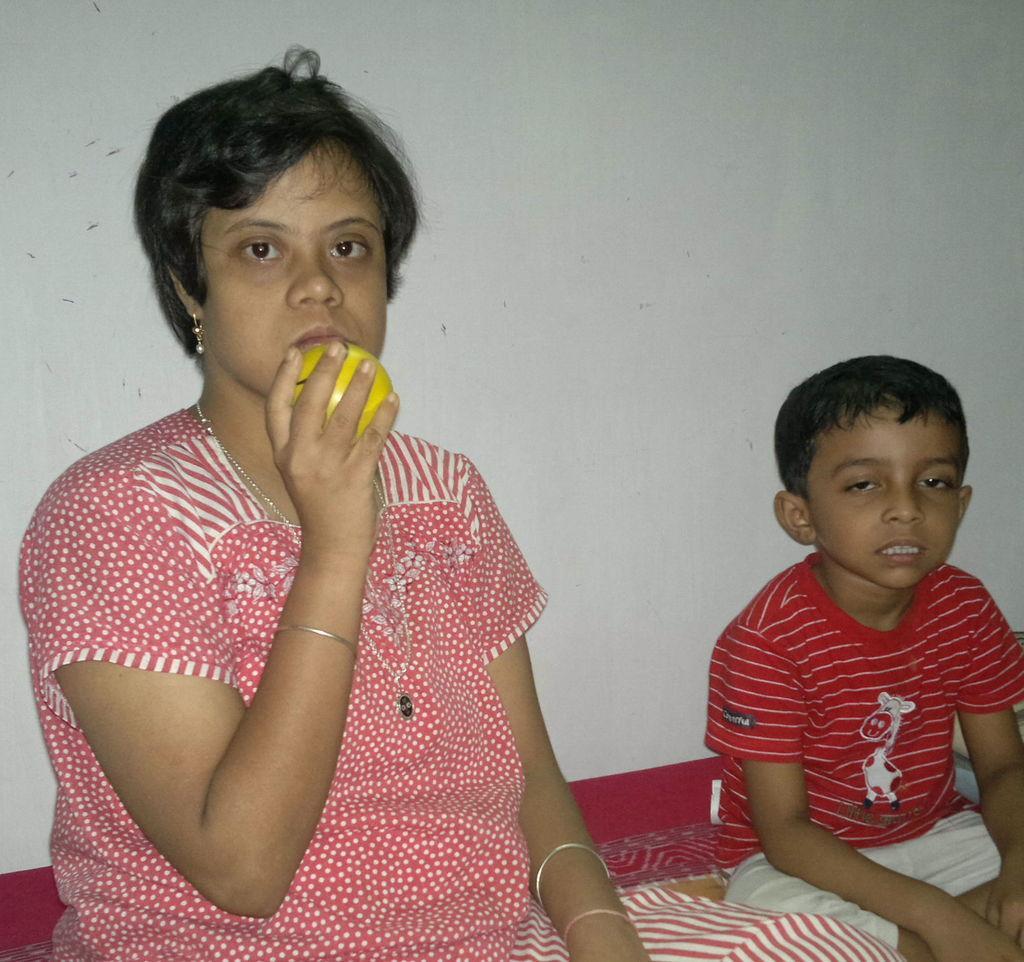Could you give a brief overview of what you see in this image? In this picture we can see a woman and a boy, they are seated, and she is holding a ball. 